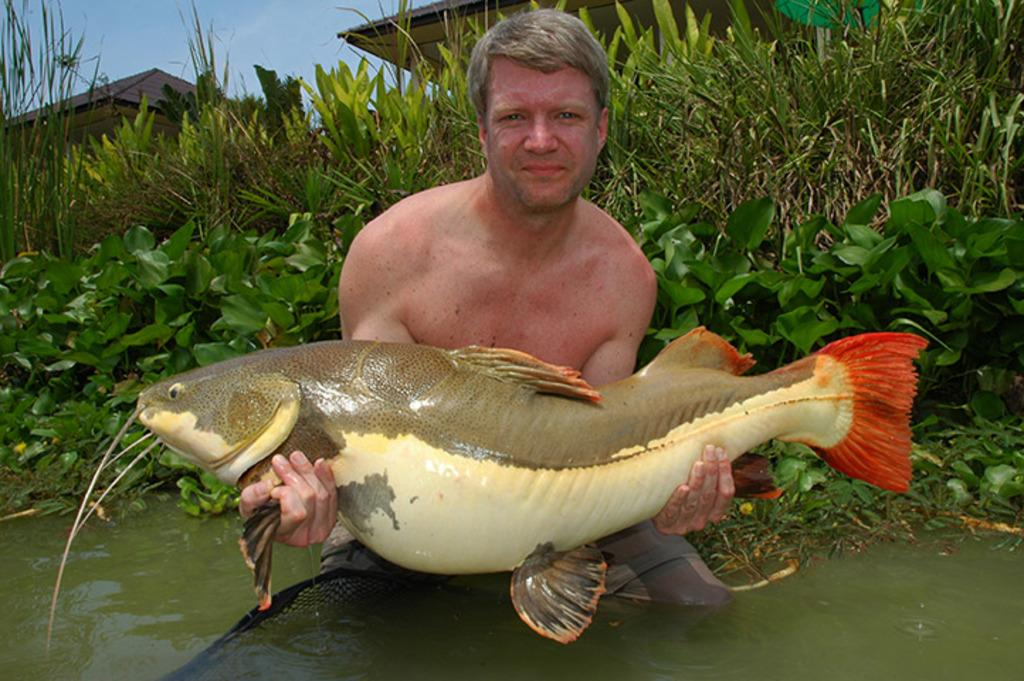Who is present in the image? There is a man in the image. What is the man holding in the image? The man is holding a fish. What can be seen at the bottom of the image? There is water at the bottom of the image. What is visible in the background of the image? There are plants and houses in the background of the image. What is visible at the top of the image? The sky is visible at the top of the image. Is there a gate visible in the image? There is no gate present in the image. Can you see any cobwebs in the image? There is no mention of cobwebs in the image, and they are not visible in the provided facts. 